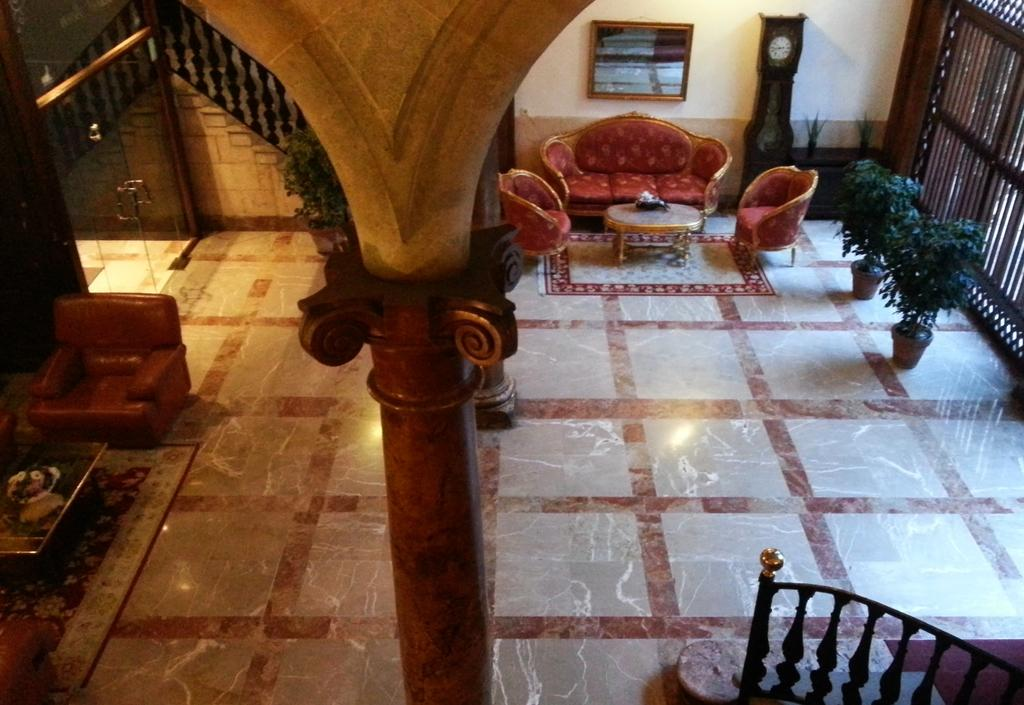What structure can be seen at the top of the image? There is a pillar at the top of the image. What feature allows access to the space in the image? There is a door in the image. What type of furniture is present in the image? There are chairs and sofas in the image. What decorative element can be seen on the tables? There are flowers on the tables. What type of surface is visible in the image? There is a floor visible in the image. What time-related object is present in the image? There is a clock in the image. What type of wood is used to make the quilt in the image? There is no quilt present in the image. How does the moon affect the lighting in the image? The image does not depict the moon or any moonlight; it is an indoor scene with artificial lighting. 